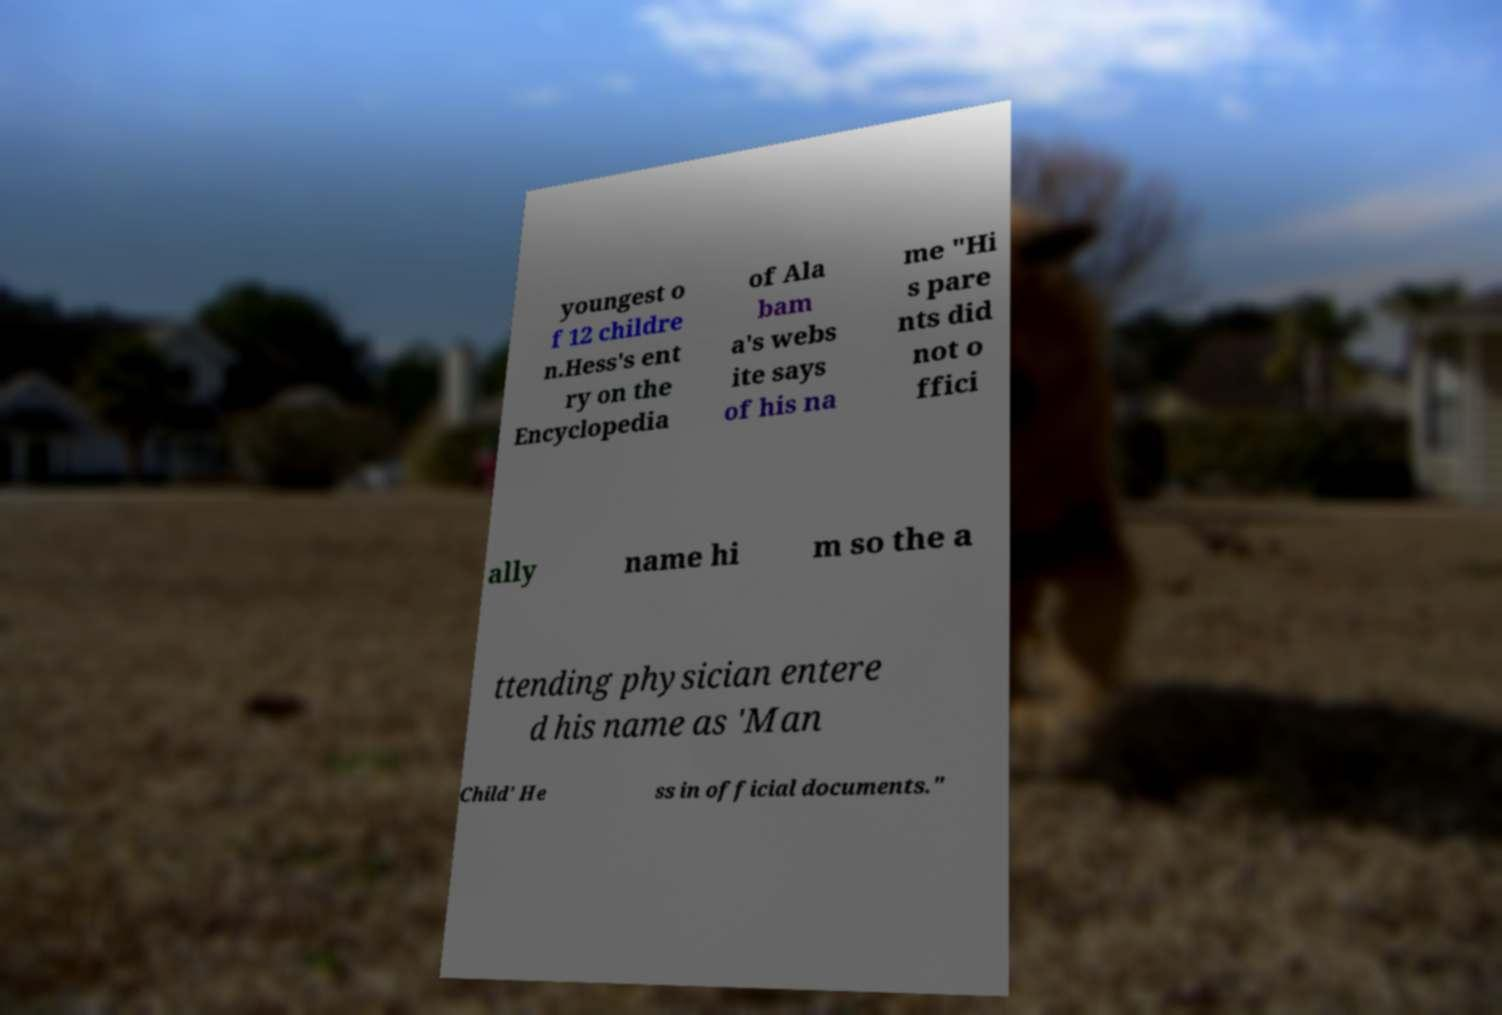Could you assist in decoding the text presented in this image and type it out clearly? youngest o f 12 childre n.Hess's ent ry on the Encyclopedia of Ala bam a's webs ite says of his na me "Hi s pare nts did not o ffici ally name hi m so the a ttending physician entere d his name as 'Man Child' He ss in official documents." 